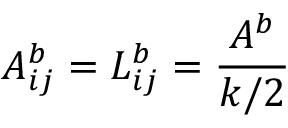<formula> <loc_0><loc_0><loc_500><loc_500>A _ { i j } ^ { b } = L _ { i j } ^ { b } = \frac { A ^ { b } } { k / 2 }</formula> 